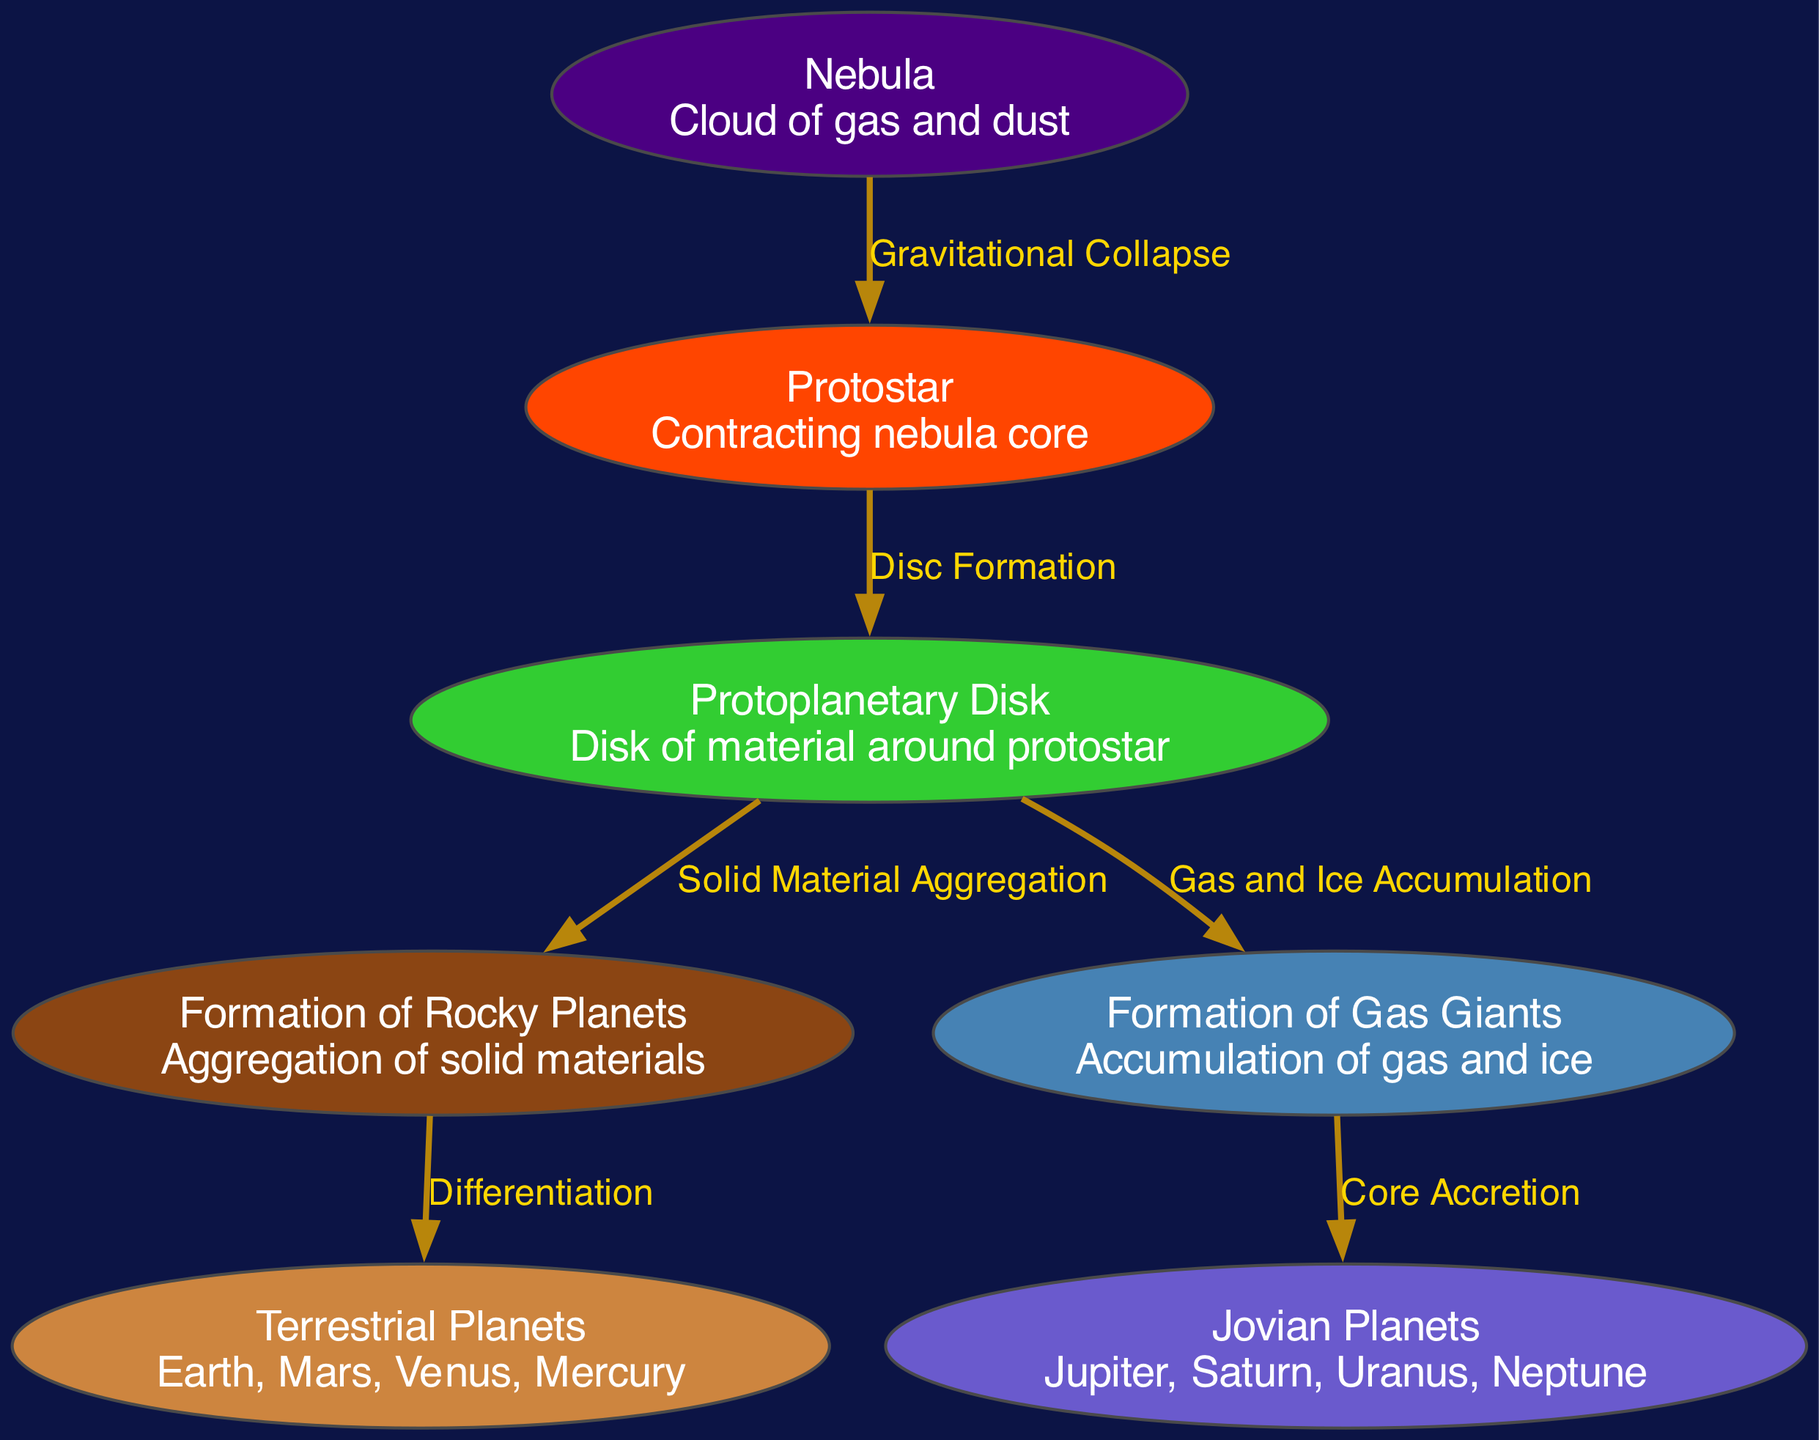What is the first stage of the formation process? The diagram shows that the first stage is labeled as "Nebula," which is described as a cloud of gas and dust.
Answer: Nebula How many nodes are present in the diagram? By counting the entries under "nodes" in the provided data, we find there are a total of seven nodes in the diagram.
Answer: 7 What process connects the nebula to the protostar? The edge labeled "Gravitational Collapse" illustrates the connection between the "Nebula" and "Protostar," indicating the action that leads to the formation of the protostar.
Answer: Gravitational Collapse Which planets are classified as terrestrial? The diagram identifies "Earth, Mars, Venus, Mercury" under the category of "Terrestrial Planets."
Answer: Earth, Mars, Venus, Mercury What is accumulated to form gas giants? The diagram indicates that "Gas and Ice Accumulation" is the process that helps in the formation of gas giants, highlighting the materials involved.
Answer: Gas and Ice How does the formation of rocky planets differ from gas giants? The formation of rocky planets involves "Aggregation of solid materials," while gas giants form through "Accumulation of gas and ice," indicating a fundamental difference in material composition.
Answer: Aggregation of solid materials; Accumulation of gas and ice What does the "Core Accretion" process lead to in the diagram? According to the diagram, the "Core Accretion" process that originates from gas giants results in the formation of "Jovian Planets," such as Jupiter, Saturn, Uranus, and Neptune.
Answer: Jovian Planets How many edges are there in the diagram? By reviewing the "edges" section in the data provided, there are six connections that illustrate the relationships between the different stages and types of planets.
Answer: 6 What is the relationship between the planetary disk and rocky planets? The diagram shows that the relationship is defined by "Solid Material Aggregation," which describes the process of materials coming together to form rocky planets.
Answer: Solid Material Aggregation 